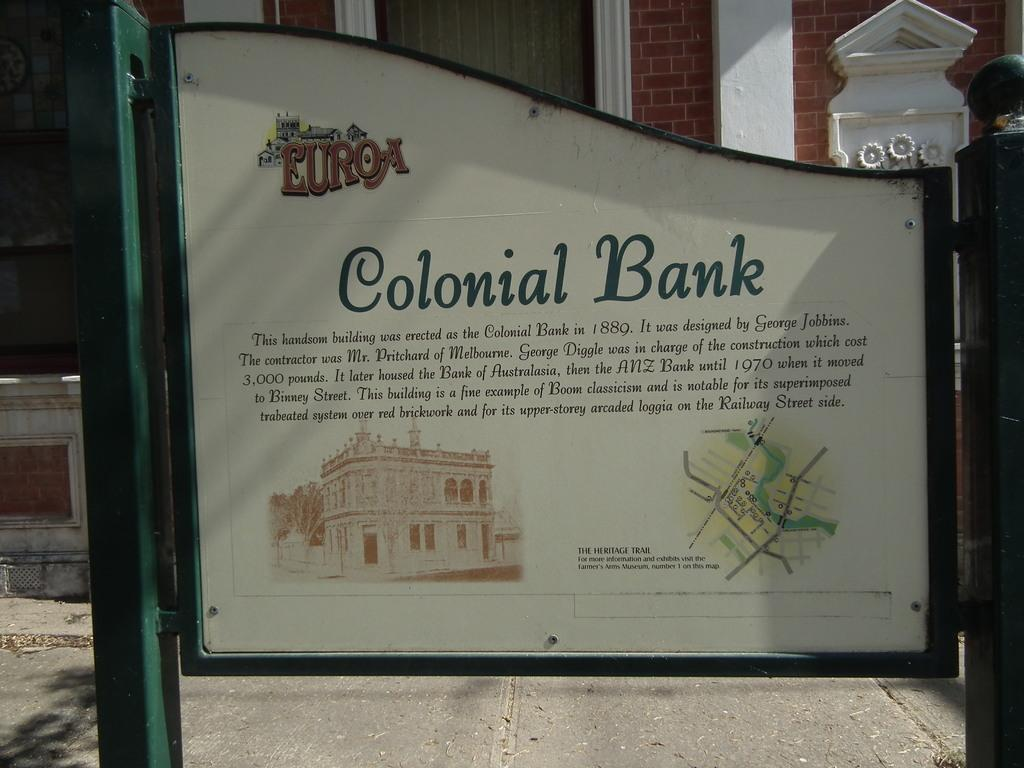<image>
Write a terse but informative summary of the picture. A sign outside of a building gives historical information on Colonial Bank. 